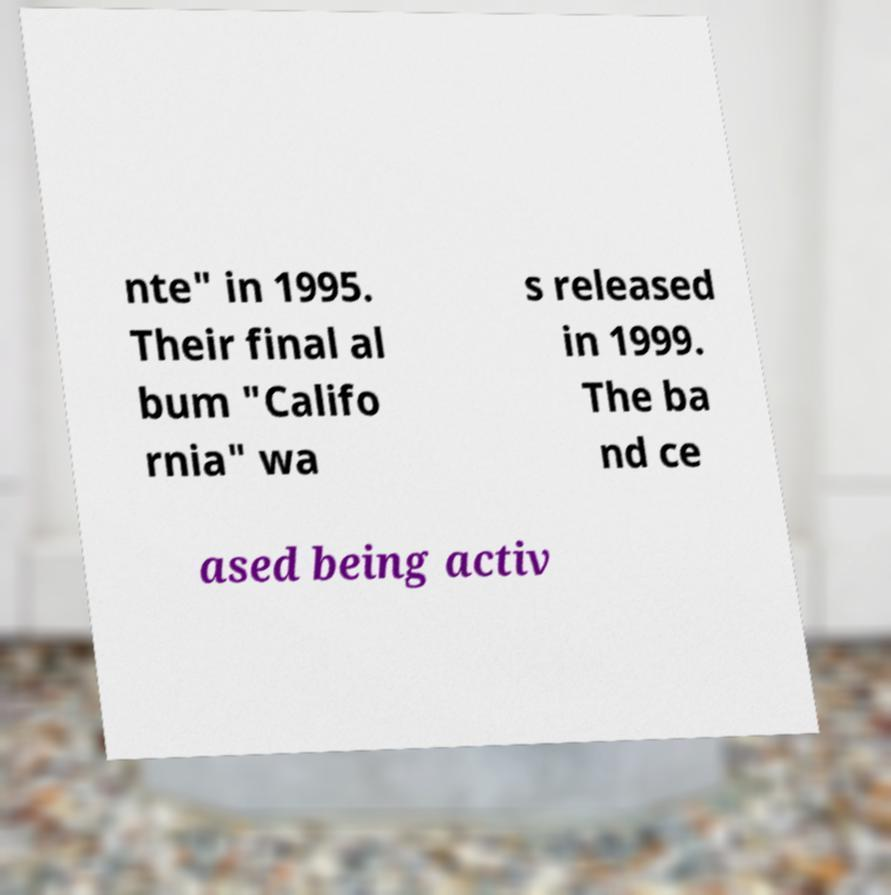Can you accurately transcribe the text from the provided image for me? nte" in 1995. Their final al bum "Califo rnia" wa s released in 1999. The ba nd ce ased being activ 